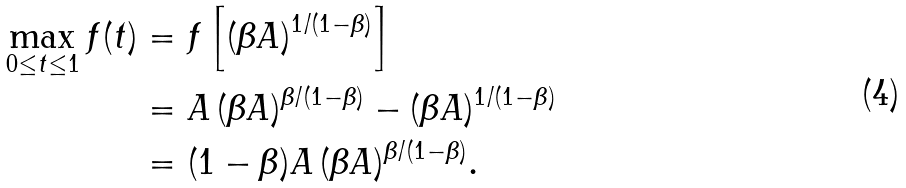<formula> <loc_0><loc_0><loc_500><loc_500>\max _ { 0 \leq t \leq 1 } f ( t ) & = f \left [ ( \beta A ) ^ { 1 / ( 1 - \beta ) } \right ] \\ & = A \, ( \beta A ) ^ { \beta / ( 1 - \beta ) } - ( \beta A ) ^ { 1 / ( 1 - \beta ) } \\ & = ( 1 - \beta ) A \, ( \beta A ) ^ { \beta / ( 1 - \beta ) } .</formula> 